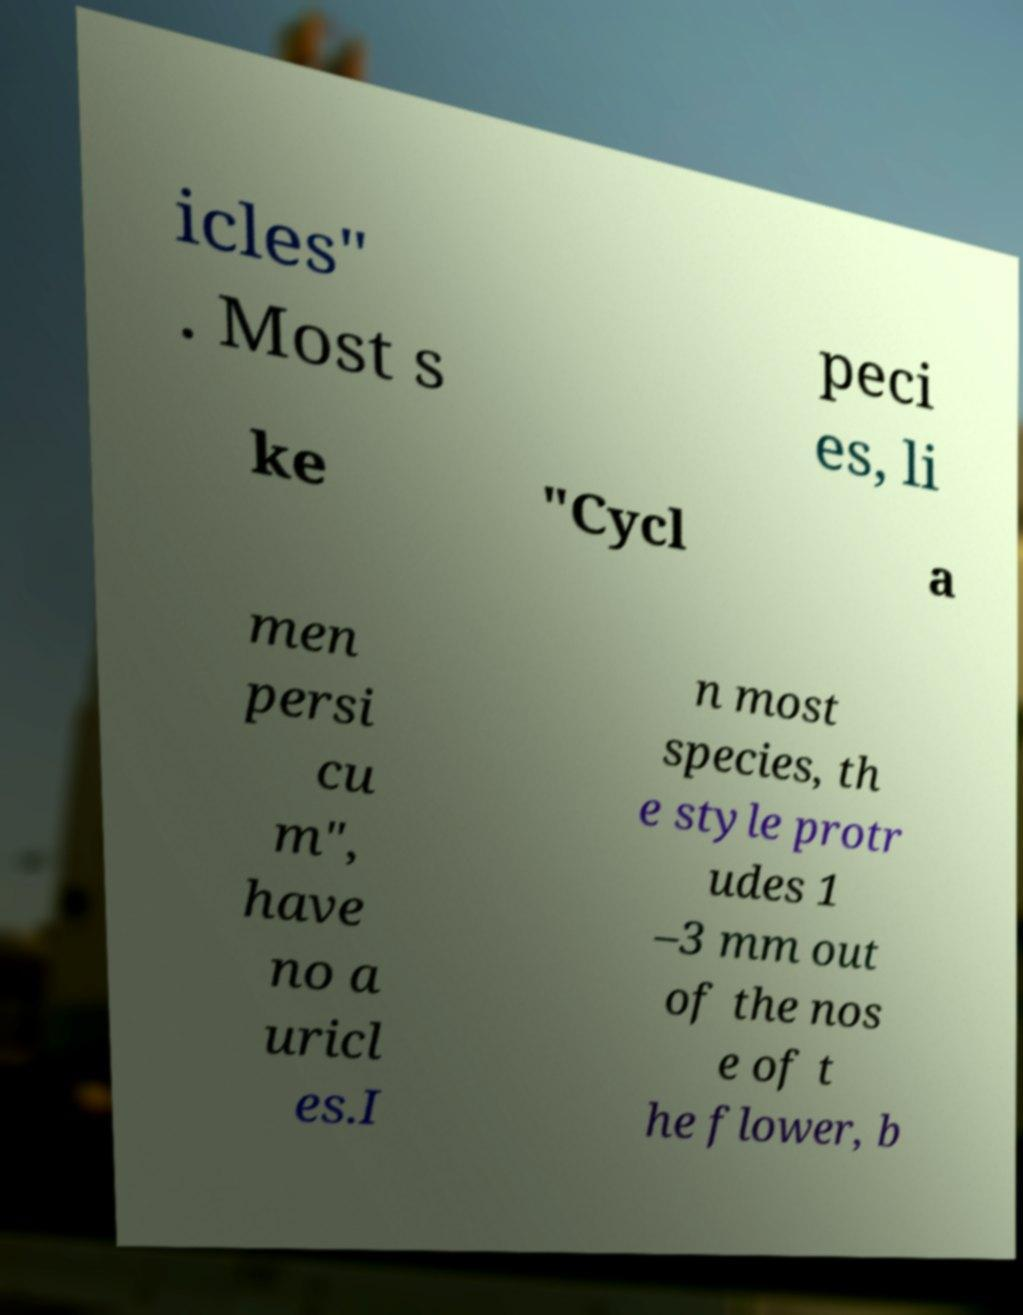For documentation purposes, I need the text within this image transcribed. Could you provide that? icles" . Most s peci es, li ke "Cycl a men persi cu m", have no a uricl es.I n most species, th e style protr udes 1 –3 mm out of the nos e of t he flower, b 